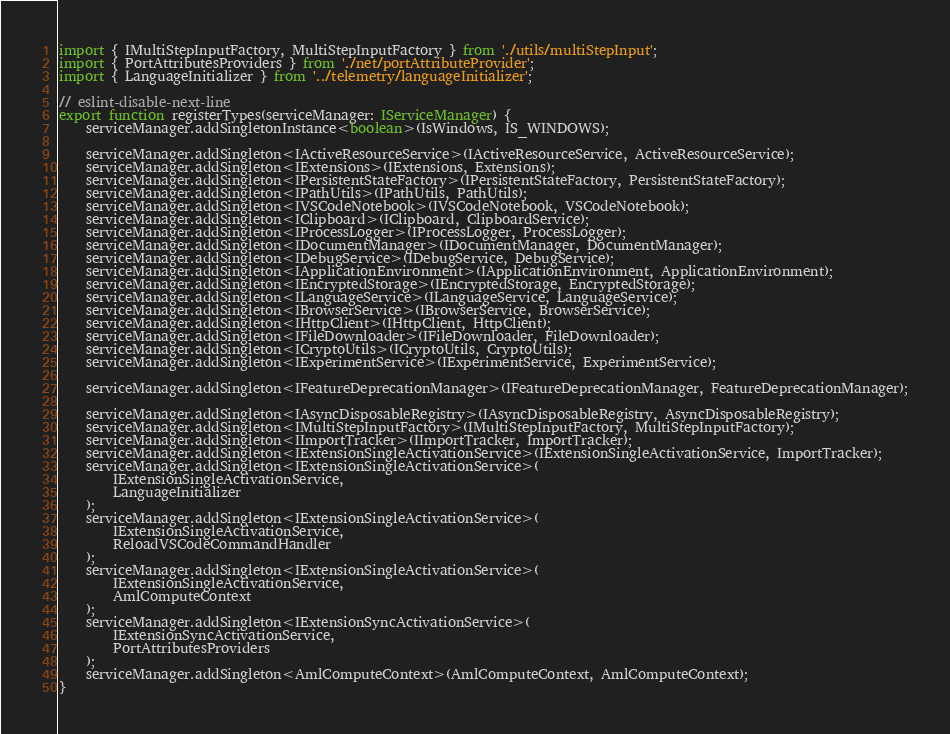<code> <loc_0><loc_0><loc_500><loc_500><_TypeScript_>import { IMultiStepInputFactory, MultiStepInputFactory } from './utils/multiStepInput';
import { PortAttributesProviders } from './net/portAttributeProvider';
import { LanguageInitializer } from '../telemetry/languageInitializer';

// eslint-disable-next-line
export function registerTypes(serviceManager: IServiceManager) {
    serviceManager.addSingletonInstance<boolean>(IsWindows, IS_WINDOWS);

    serviceManager.addSingleton<IActiveResourceService>(IActiveResourceService, ActiveResourceService);
    serviceManager.addSingleton<IExtensions>(IExtensions, Extensions);
    serviceManager.addSingleton<IPersistentStateFactory>(IPersistentStateFactory, PersistentStateFactory);
    serviceManager.addSingleton<IPathUtils>(IPathUtils, PathUtils);
    serviceManager.addSingleton<IVSCodeNotebook>(IVSCodeNotebook, VSCodeNotebook);
    serviceManager.addSingleton<IClipboard>(IClipboard, ClipboardService);
    serviceManager.addSingleton<IProcessLogger>(IProcessLogger, ProcessLogger);
    serviceManager.addSingleton<IDocumentManager>(IDocumentManager, DocumentManager);
    serviceManager.addSingleton<IDebugService>(IDebugService, DebugService);
    serviceManager.addSingleton<IApplicationEnvironment>(IApplicationEnvironment, ApplicationEnvironment);
    serviceManager.addSingleton<IEncryptedStorage>(IEncryptedStorage, EncryptedStorage);
    serviceManager.addSingleton<ILanguageService>(ILanguageService, LanguageService);
    serviceManager.addSingleton<IBrowserService>(IBrowserService, BrowserService);
    serviceManager.addSingleton<IHttpClient>(IHttpClient, HttpClient);
    serviceManager.addSingleton<IFileDownloader>(IFileDownloader, FileDownloader);
    serviceManager.addSingleton<ICryptoUtils>(ICryptoUtils, CryptoUtils);
    serviceManager.addSingleton<IExperimentService>(IExperimentService, ExperimentService);

    serviceManager.addSingleton<IFeatureDeprecationManager>(IFeatureDeprecationManager, FeatureDeprecationManager);

    serviceManager.addSingleton<IAsyncDisposableRegistry>(IAsyncDisposableRegistry, AsyncDisposableRegistry);
    serviceManager.addSingleton<IMultiStepInputFactory>(IMultiStepInputFactory, MultiStepInputFactory);
    serviceManager.addSingleton<IImportTracker>(IImportTracker, ImportTracker);
    serviceManager.addSingleton<IExtensionSingleActivationService>(IExtensionSingleActivationService, ImportTracker);
    serviceManager.addSingleton<IExtensionSingleActivationService>(
        IExtensionSingleActivationService,
        LanguageInitializer
    );
    serviceManager.addSingleton<IExtensionSingleActivationService>(
        IExtensionSingleActivationService,
        ReloadVSCodeCommandHandler
    );
    serviceManager.addSingleton<IExtensionSingleActivationService>(
        IExtensionSingleActivationService,
        AmlComputeContext
    );
    serviceManager.addSingleton<IExtensionSyncActivationService>(
        IExtensionSyncActivationService,
        PortAttributesProviders
    );
    serviceManager.addSingleton<AmlComputeContext>(AmlComputeContext, AmlComputeContext);
}
</code> 